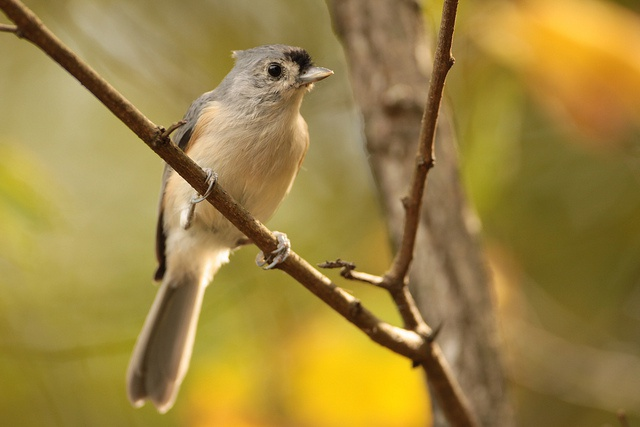Describe the objects in this image and their specific colors. I can see a bird in maroon, tan, olive, and gray tones in this image. 